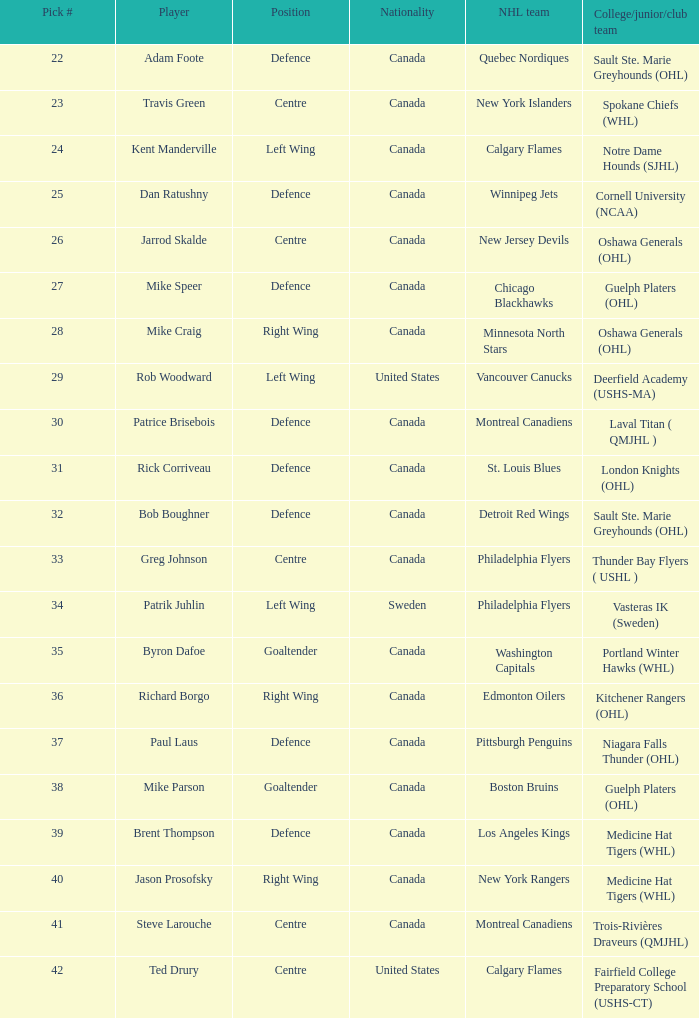Which nhl team chose richard borgo? Edmonton Oilers. 